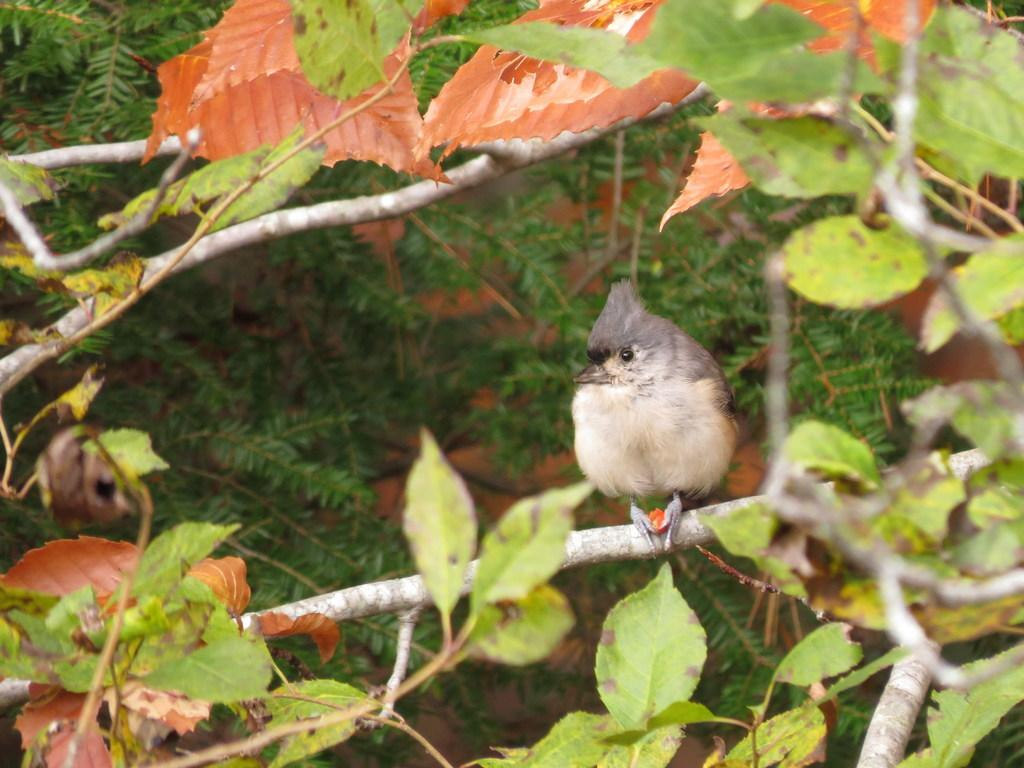Where was the image taken? The image was taken outdoors. What type of vegetation can be seen in the image? There are trees with leaves, stems, and branches in the image. Can you describe the bird in the image? There is a bird on the branch of a tree in the image. How much money is the rose holding in the image? There is no rose or money present in the image. 